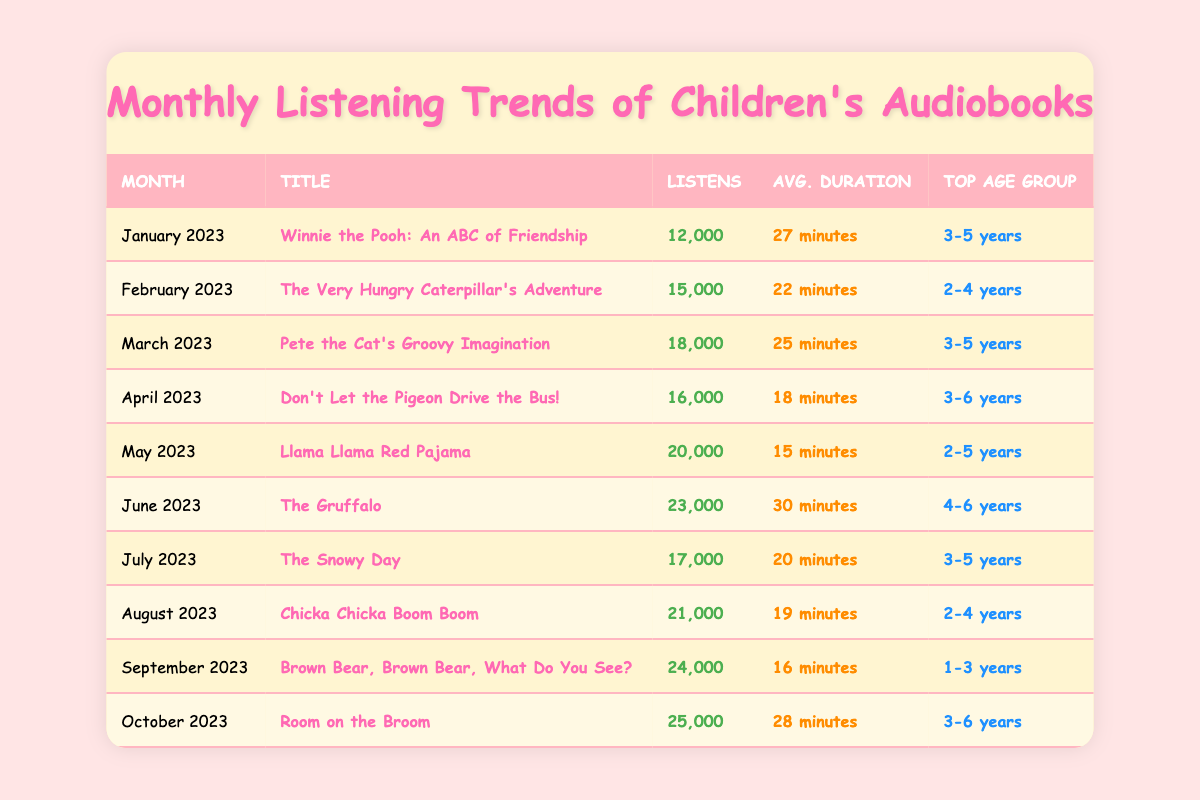What's the title of the audiobook listened to the most in October 2023? The title for October 2023 is "Room on the Broom," which has the highest listens for that month at 25,000.
Answer: Room on the Broom Which audiobook had the highest number of listens overall? The audiobook with the highest listens overall is "Room on the Broom" with 25,000 listens.
Answer: Room on the Broom What is the average duration of "The Gruffalo"? The average duration for "The Gruffalo" is stated as 30 minutes.
Answer: 30 minutes In which month was "The Very Hungry Caterpillar's Adventure" released? "The Very Hungry Caterpillar's Adventure" was released in February 2023.
Answer: February 2023 How many listens did "Llama Llama Red Pajama" get? "Llama Llama Red Pajama" received 20,000 listens according to the table.
Answer: 20,000 listens Which audiobook has the top age group of "1-3 years"? The audiobook "Brown Bear, Brown Bear, What Do You See?" has the top age group of "1-3 years" as per the data.
Answer: Brown Bear, Brown Bear, What Do You See? What is the total number of listens for audiobooks from January to March? The total listens from January (12,000), February (15,000), and March (18,000) is 12,000 + 15,000 + 18,000 = 45,000.
Answer: 45,000 Which month had the lowest average duration and what was it? The lowest average duration was in May 2023 for "Llama Llama Red Pajama," which lasted 15 minutes.
Answer: May 2023, 15 minutes How many listens did the audiobook with the title "Don't Let the Pigeon Drive the Bus!" get compared to "The Snowy Day"? "Don't Let the Pigeon Drive the Bus!" had 16,000 listens, while "The Snowy Day" had 17,000 listens; hence, "The Snowy Day" had 1,000 more listens than "Don't Let the Pigeon Drive the Bus!".
Answer: 1,000 more listens What is the average number of listens for the audiobooks released in the second half of the year (July to October)? The listens for July (17,000), August (21,000), September (24,000), and October (25,000) total to 87,000, and dividing by 4 gives an average of 21,750.
Answer: 21,750 